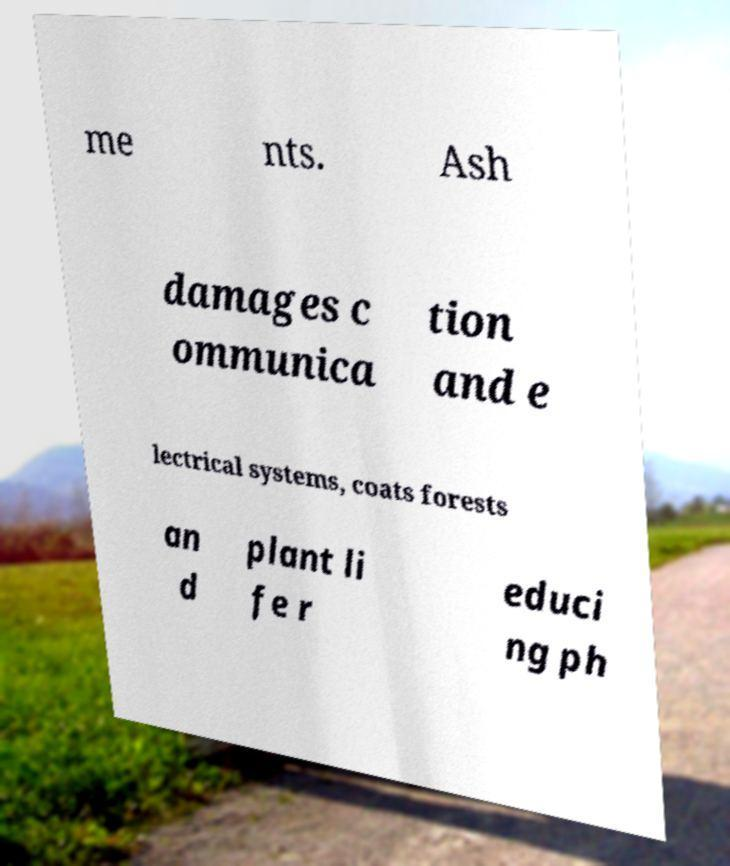I need the written content from this picture converted into text. Can you do that? me nts. Ash damages c ommunica tion and e lectrical systems, coats forests an d plant li fe r educi ng ph 